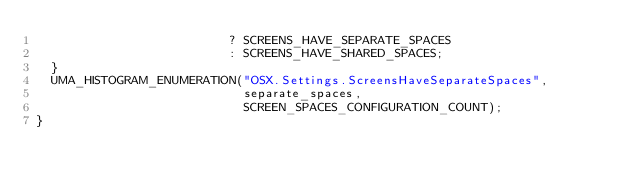<code> <loc_0><loc_0><loc_500><loc_500><_ObjectiveC_>                          ? SCREENS_HAVE_SEPARATE_SPACES
                          : SCREENS_HAVE_SHARED_SPACES;
  }
  UMA_HISTOGRAM_ENUMERATION("OSX.Settings.ScreensHaveSeparateSpaces",
                            separate_spaces,
                            SCREEN_SPACES_CONFIGURATION_COUNT);
}
</code> 